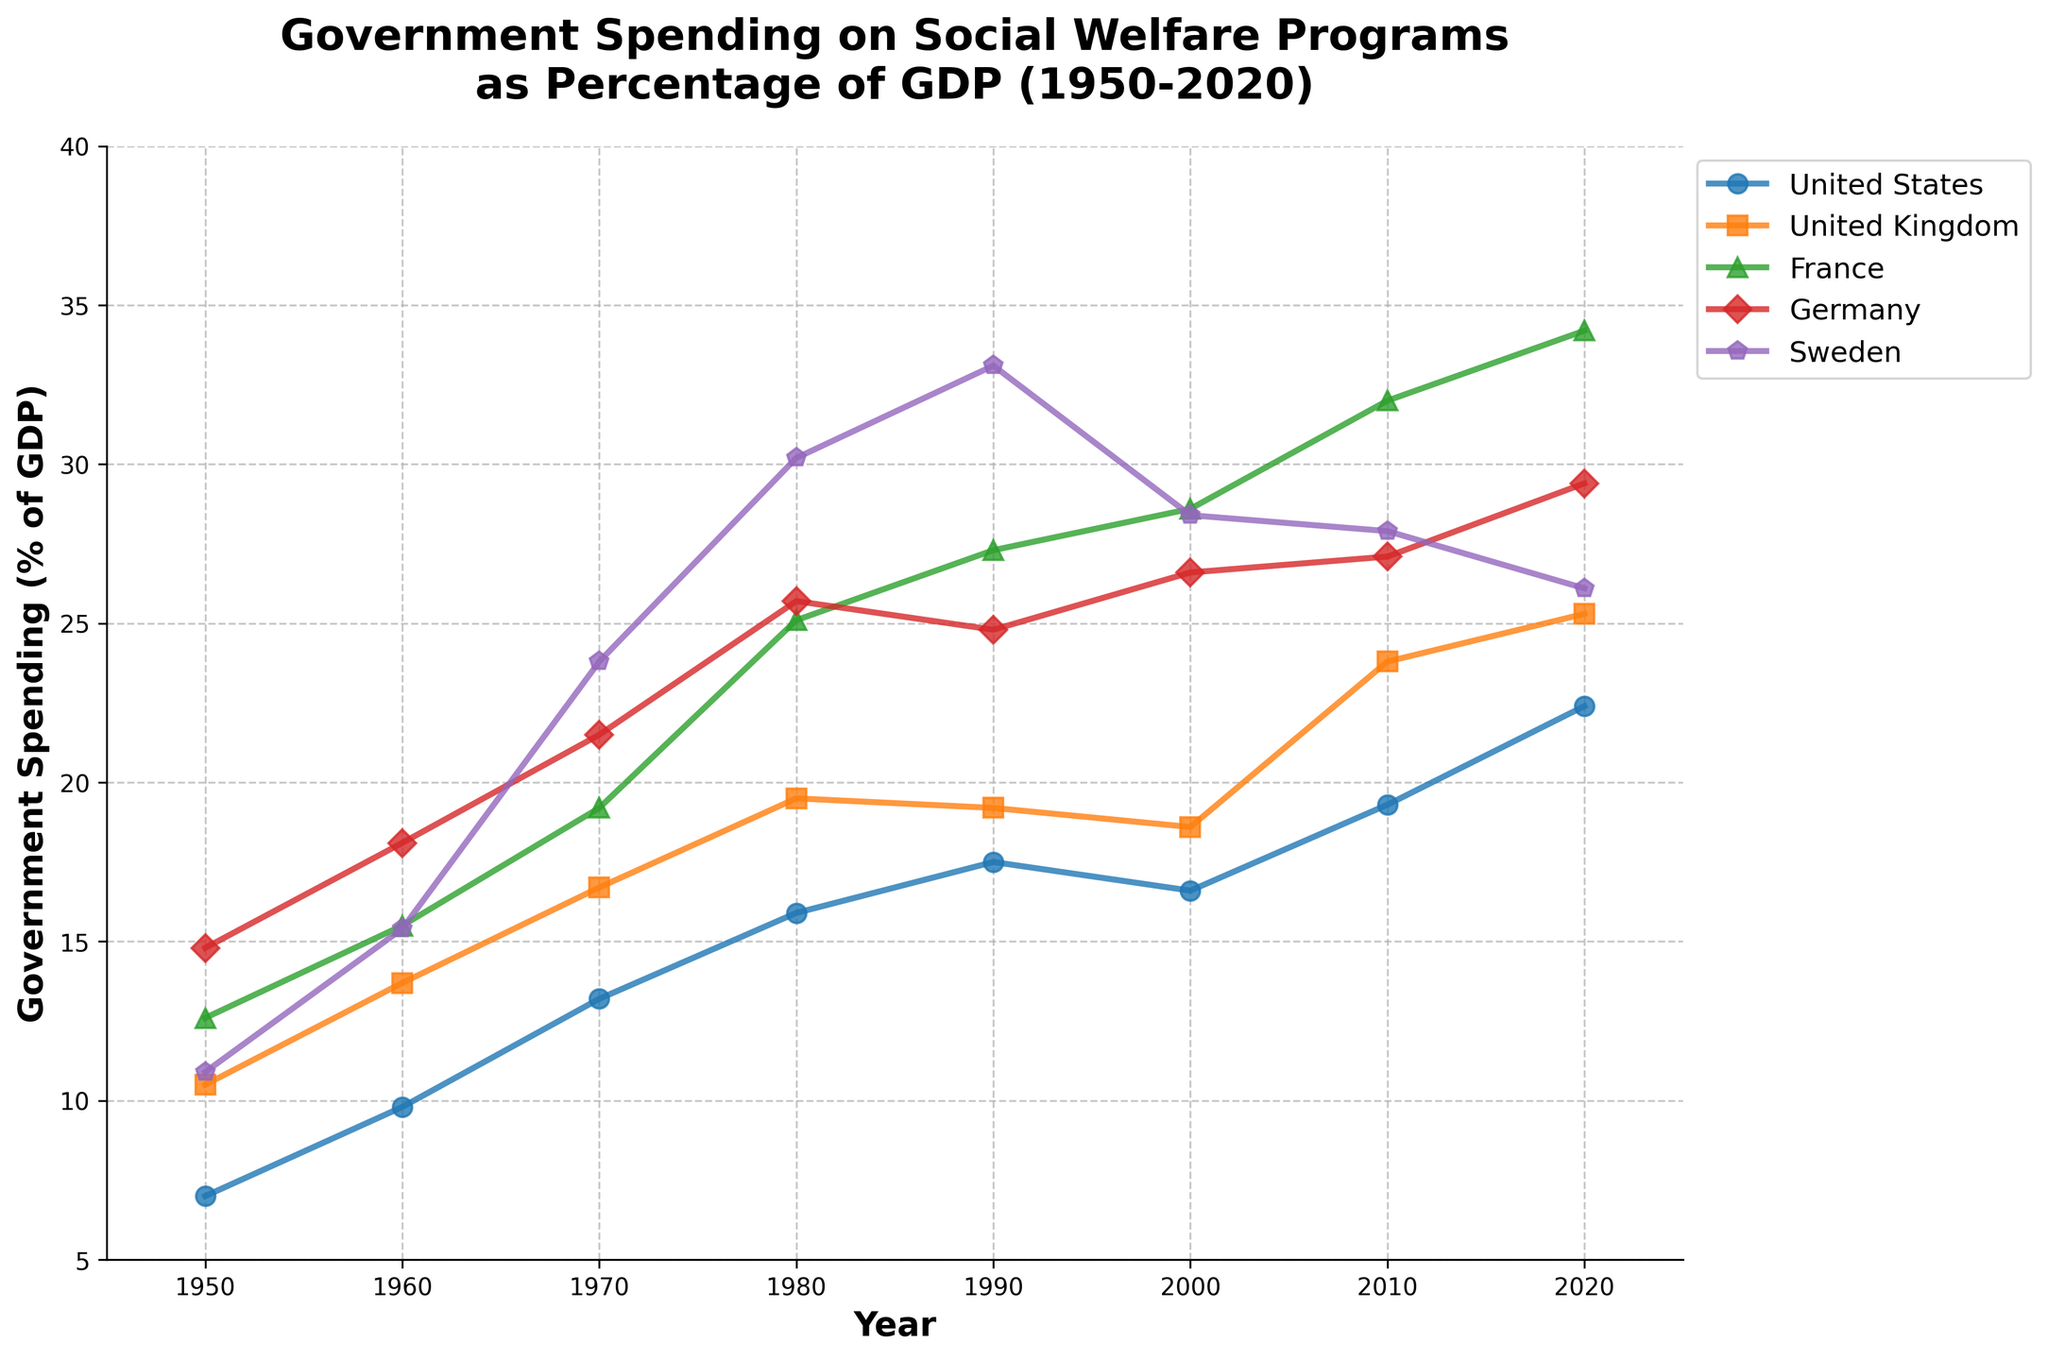What year did the United States surpass 15% GDP in government spending on social welfare programs? By tracing the line corresponding to the United States, we see that the percentage surpasses 15% between 1970 and 1980. Identifying the specific point, it is evident that in 1980, the spending reached 15.9%.
Answer: 1980 Which country had the highest percentage of GDP spent on social welfare programs in 1980? By comparing the heights of the points for each country in 1980, Sweden has the highest percentage at 30.2%.
Answer: Sweden From 2000 to 2020, which country showed the largest increase in government spending on social welfare programs as a percentage of GDP? To find the largest increase, subtract the 2000 value from the 2020 value for each country: 
United States: 22.4 - 16.6 = 5.8;
United Kingdom: 25.3 - 18.6 = 6.7;
France: 34.2 - 28.6 = 5.6;
Germany: 29.4 - 26.6 = 2.8;
Sweden: 26.1 - 28.4 = -2.3;
The United Kingdom has the largest increase of 6.7%.
Answer: United Kingdom Which countries showed a decrease in their percentage of GDP spent on social welfare programs from 1990 to 2000? By checking the values for each country, the United States (from 17.5 to 16.6), United Kingdom (from 19.2 to 18.6), and Sweden (from 33.1 to 28.4) showed decreases. All three had decreasing lines in this period.
Answer: United States, United Kingdom, and Sweden What is the average government spending on social welfare programs as a percentage of GDP for France from 1950 to 2020? Sum the values for France and divide by the number of years recorded: (12.6 + 15.5 + 19.2 + 25.1 + 27.3 + 28.6 + 32.0 + 34.2) / 8 = 194.5 / 8 ≈ 24.31.
Answer: 24.31 In which decade did Germany see the steepest increase in social welfare spending as a percentage of GDP? By observing the slopes between the points, the steepest increase for Germany is between 1950 and 1960, where the percentage increased from 14.8% to 18.1%, which is an increase of 3.3%.
Answer: 1950-1960 How does Sweden's social welfare spending as a percentage of GDP in 2020 compare to 1960? Compare the heights (y-values) for Sweden in 2020 (26.1%) and 1960 (15.4%). The 2020 value is higher by 10.7%.
Answer: 10.7% higher Which country had the smallest variation in government spending percentage from 1950 to 2020? Calculate the range (maximum - minimum) for each country:
United States: 22.4 - 7.0 = 15.4;
United Kingdom: 25.3 - 10.5 = 14.8;
France: 34.2 - 12.6 = 21.6;
Germany: 29.4 - 14.8 = 14.6;
Sweden: 33.1 - 10.9 = 22.2;
Germany has the smallest variation of 14.6%.
Answer: Germany What was the trend in the United Kingdom's social welfare spending from 1970 to 1990? By observing the line for the United Kingdom between these years, we see an increase from 16.7% (1970) to 19.5% (1980), followed by a slight decrease to 19.2% (1990).
Answer: Increase then slight decrease What is the median value of government spending for the United States over the period? Organize the values for the United States in ascending order: 7.0, 9.8, 13.2, 15.9, 16.6, 17.5, 19.3, 22.4.
Since there are 8 values, the median is the average of the 4th and 5th values: (15.9 + 16.6) / 2 = 16.25.
Answer: 16.25 